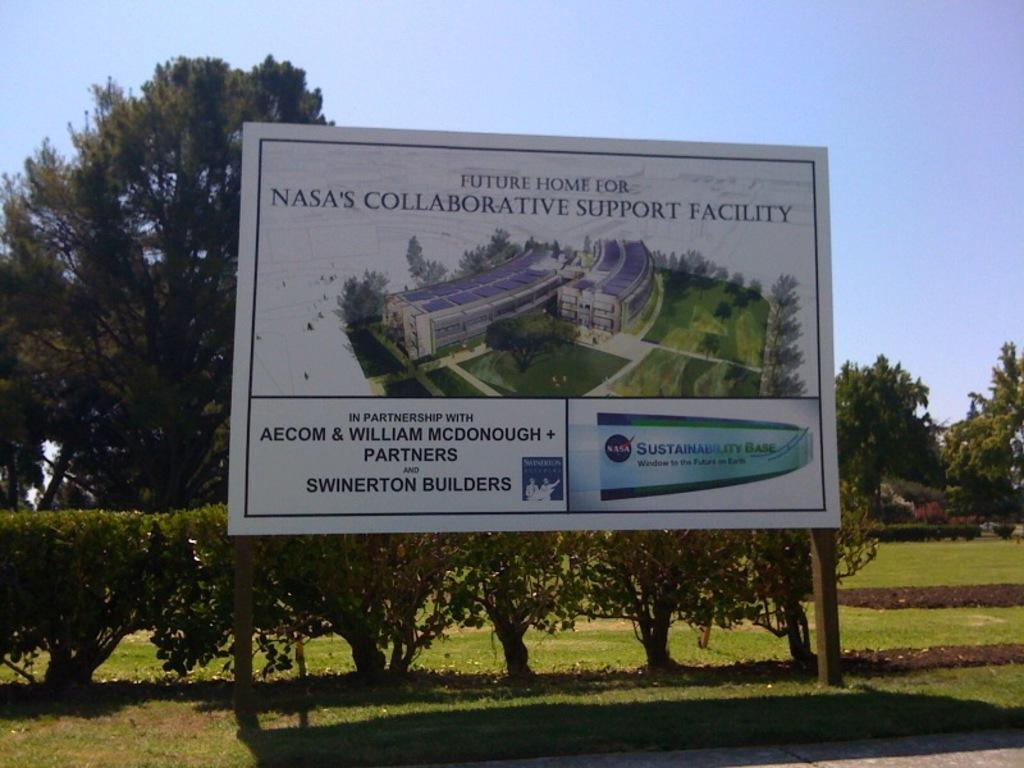<image>
Create a compact narrative representing the image presented. A billboard announces plans for a future NASA building. 